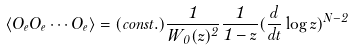<formula> <loc_0><loc_0><loc_500><loc_500>\langle O _ { e } O _ { e } \cdots O _ { e } \rangle = ( c o n s t . ) \frac { 1 } { W _ { 0 } ( z ) ^ { 2 } } \frac { 1 } { 1 - z } ( \frac { d } { d t } \log z ) ^ { N - 2 }</formula> 